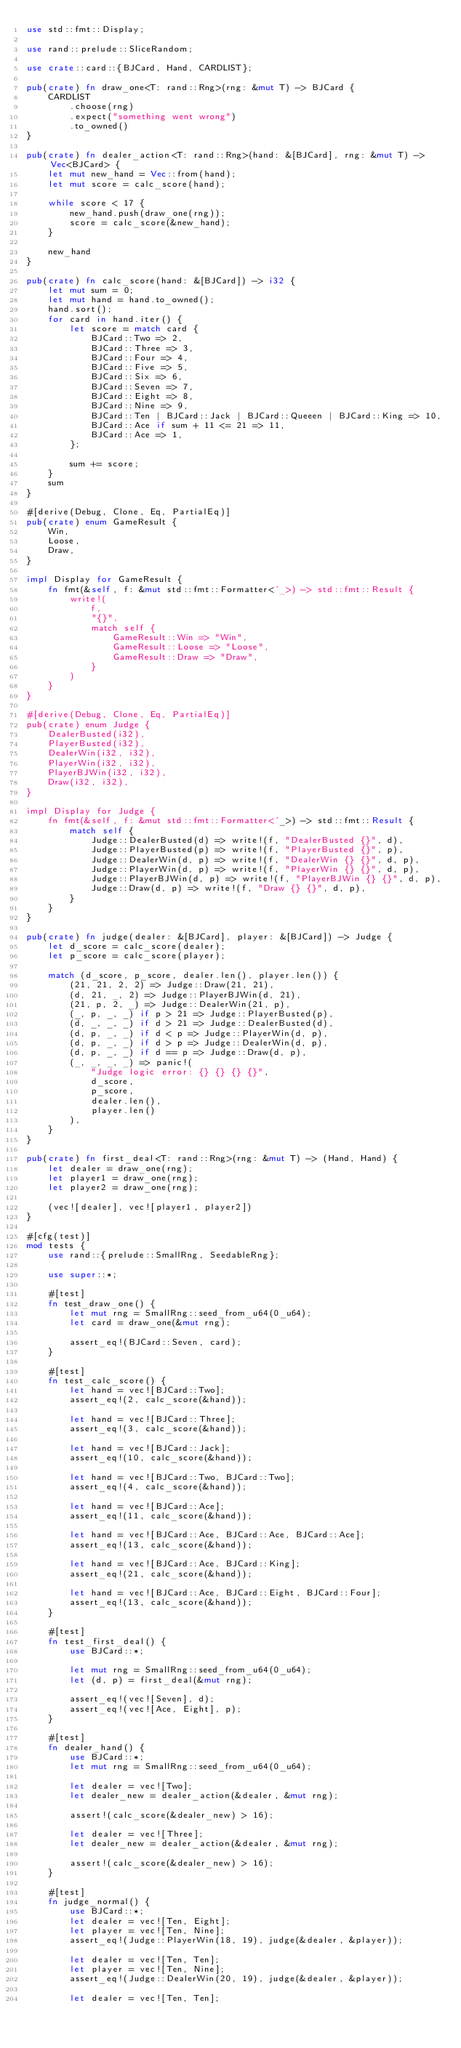<code> <loc_0><loc_0><loc_500><loc_500><_Rust_>use std::fmt::Display;

use rand::prelude::SliceRandom;

use crate::card::{BJCard, Hand, CARDLIST};

pub(crate) fn draw_one<T: rand::Rng>(rng: &mut T) -> BJCard {
    CARDLIST
        .choose(rng)
        .expect("something went wrong")
        .to_owned()
}

pub(crate) fn dealer_action<T: rand::Rng>(hand: &[BJCard], rng: &mut T) -> Vec<BJCard> {
    let mut new_hand = Vec::from(hand);
    let mut score = calc_score(hand);

    while score < 17 {
        new_hand.push(draw_one(rng));
        score = calc_score(&new_hand);
    }

    new_hand
}

pub(crate) fn calc_score(hand: &[BJCard]) -> i32 {
    let mut sum = 0;
    let mut hand = hand.to_owned();
    hand.sort();
    for card in hand.iter() {
        let score = match card {
            BJCard::Two => 2,
            BJCard::Three => 3,
            BJCard::Four => 4,
            BJCard::Five => 5,
            BJCard::Six => 6,
            BJCard::Seven => 7,
            BJCard::Eight => 8,
            BJCard::Nine => 9,
            BJCard::Ten | BJCard::Jack | BJCard::Queeen | BJCard::King => 10,
            BJCard::Ace if sum + 11 <= 21 => 11,
            BJCard::Ace => 1,
        };

        sum += score;
    }
    sum
}

#[derive(Debug, Clone, Eq, PartialEq)]
pub(crate) enum GameResult {
    Win,
    Loose,
    Draw,
}

impl Display for GameResult {
    fn fmt(&self, f: &mut std::fmt::Formatter<'_>) -> std::fmt::Result {
        write!(
            f,
            "{}",
            match self {
                GameResult::Win => "Win",
                GameResult::Loose => "Loose",
                GameResult::Draw => "Draw",
            }
        )
    }
}

#[derive(Debug, Clone, Eq, PartialEq)]
pub(crate) enum Judge {
    DealerBusted(i32),
    PlayerBusted(i32),
    DealerWin(i32, i32),
    PlayerWin(i32, i32),
    PlayerBJWin(i32, i32),
    Draw(i32, i32),
}

impl Display for Judge {
    fn fmt(&self, f: &mut std::fmt::Formatter<'_>) -> std::fmt::Result {
        match self {
            Judge::DealerBusted(d) => write!(f, "DealerBusted {}", d),
            Judge::PlayerBusted(p) => write!(f, "PlayerBusted {}", p),
            Judge::DealerWin(d, p) => write!(f, "DealerWin {} {}", d, p),
            Judge::PlayerWin(d, p) => write!(f, "PlayerWin {} {}", d, p),
            Judge::PlayerBJWin(d, p) => write!(f, "PlayerBJWin {} {}", d, p),
            Judge::Draw(d, p) => write!(f, "Draw {} {}", d, p),
        }
    }
}

pub(crate) fn judge(dealer: &[BJCard], player: &[BJCard]) -> Judge {
    let d_score = calc_score(dealer);
    let p_score = calc_score(player);

    match (d_score, p_score, dealer.len(), player.len()) {
        (21, 21, 2, 2) => Judge::Draw(21, 21),
        (d, 21, _, 2) => Judge::PlayerBJWin(d, 21),
        (21, p, 2, _) => Judge::DealerWin(21, p),
        (_, p, _, _) if p > 21 => Judge::PlayerBusted(p),
        (d, _, _, _) if d > 21 => Judge::DealerBusted(d),
        (d, p, _, _) if d < p => Judge::PlayerWin(d, p),
        (d, p, _, _) if d > p => Judge::DealerWin(d, p),
        (d, p, _, _) if d == p => Judge::Draw(d, p),
        (_, _, _, _) => panic!(
            "Judge logic error: {} {} {} {}",
            d_score,
            p_score,
            dealer.len(),
            player.len()
        ),
    }
}

pub(crate) fn first_deal<T: rand::Rng>(rng: &mut T) -> (Hand, Hand) {
    let dealer = draw_one(rng);
    let player1 = draw_one(rng);
    let player2 = draw_one(rng);

    (vec![dealer], vec![player1, player2])
}

#[cfg(test)]
mod tests {
    use rand::{prelude::SmallRng, SeedableRng};

    use super::*;

    #[test]
    fn test_draw_one() {
        let mut rng = SmallRng::seed_from_u64(0_u64);
        let card = draw_one(&mut rng);

        assert_eq!(BJCard::Seven, card);
    }

    #[test]
    fn test_calc_score() {
        let hand = vec![BJCard::Two];
        assert_eq!(2, calc_score(&hand));

        let hand = vec![BJCard::Three];
        assert_eq!(3, calc_score(&hand));

        let hand = vec![BJCard::Jack];
        assert_eq!(10, calc_score(&hand));

        let hand = vec![BJCard::Two, BJCard::Two];
        assert_eq!(4, calc_score(&hand));

        let hand = vec![BJCard::Ace];
        assert_eq!(11, calc_score(&hand));

        let hand = vec![BJCard::Ace, BJCard::Ace, BJCard::Ace];
        assert_eq!(13, calc_score(&hand));

        let hand = vec![BJCard::Ace, BJCard::King];
        assert_eq!(21, calc_score(&hand));

        let hand = vec![BJCard::Ace, BJCard::Eight, BJCard::Four];
        assert_eq!(13, calc_score(&hand));
    }

    #[test]
    fn test_first_deal() {
        use BJCard::*;

        let mut rng = SmallRng::seed_from_u64(0_u64);
        let (d, p) = first_deal(&mut rng);

        assert_eq!(vec![Seven], d);
        assert_eq!(vec![Ace, Eight], p);
    }

    #[test]
    fn dealer_hand() {
        use BJCard::*;
        let mut rng = SmallRng::seed_from_u64(0_u64);

        let dealer = vec![Two];
        let dealer_new = dealer_action(&dealer, &mut rng);

        assert!(calc_score(&dealer_new) > 16);

        let dealer = vec![Three];
        let dealer_new = dealer_action(&dealer, &mut rng);

        assert!(calc_score(&dealer_new) > 16);
    }

    #[test]
    fn judge_normal() {
        use BJCard::*;
        let dealer = vec![Ten, Eight];
        let player = vec![Ten, Nine];
        assert_eq!(Judge::PlayerWin(18, 19), judge(&dealer, &player));

        let dealer = vec![Ten, Ten];
        let player = vec![Ten, Nine];
        assert_eq!(Judge::DealerWin(20, 19), judge(&dealer, &player));

        let dealer = vec![Ten, Ten];</code> 